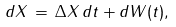Convert formula to latex. <formula><loc_0><loc_0><loc_500><loc_500>d X \, = \, \Delta X \, d t + d W ( t ) ,</formula> 